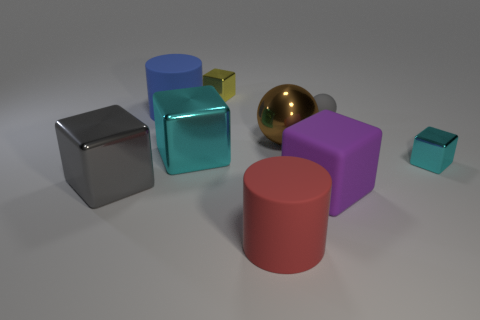Subtract 1 blocks. How many blocks are left? 4 Subtract all large purple blocks. How many blocks are left? 4 Subtract all brown cubes. Subtract all gray cylinders. How many cubes are left? 5 Add 1 gray shiny blocks. How many objects exist? 10 Subtract all cylinders. How many objects are left? 7 Add 8 red rubber things. How many red rubber things are left? 9 Add 7 tiny cyan metallic cubes. How many tiny cyan metallic cubes exist? 8 Subtract 0 cyan spheres. How many objects are left? 9 Subtract all large gray metal objects. Subtract all big gray metal things. How many objects are left? 7 